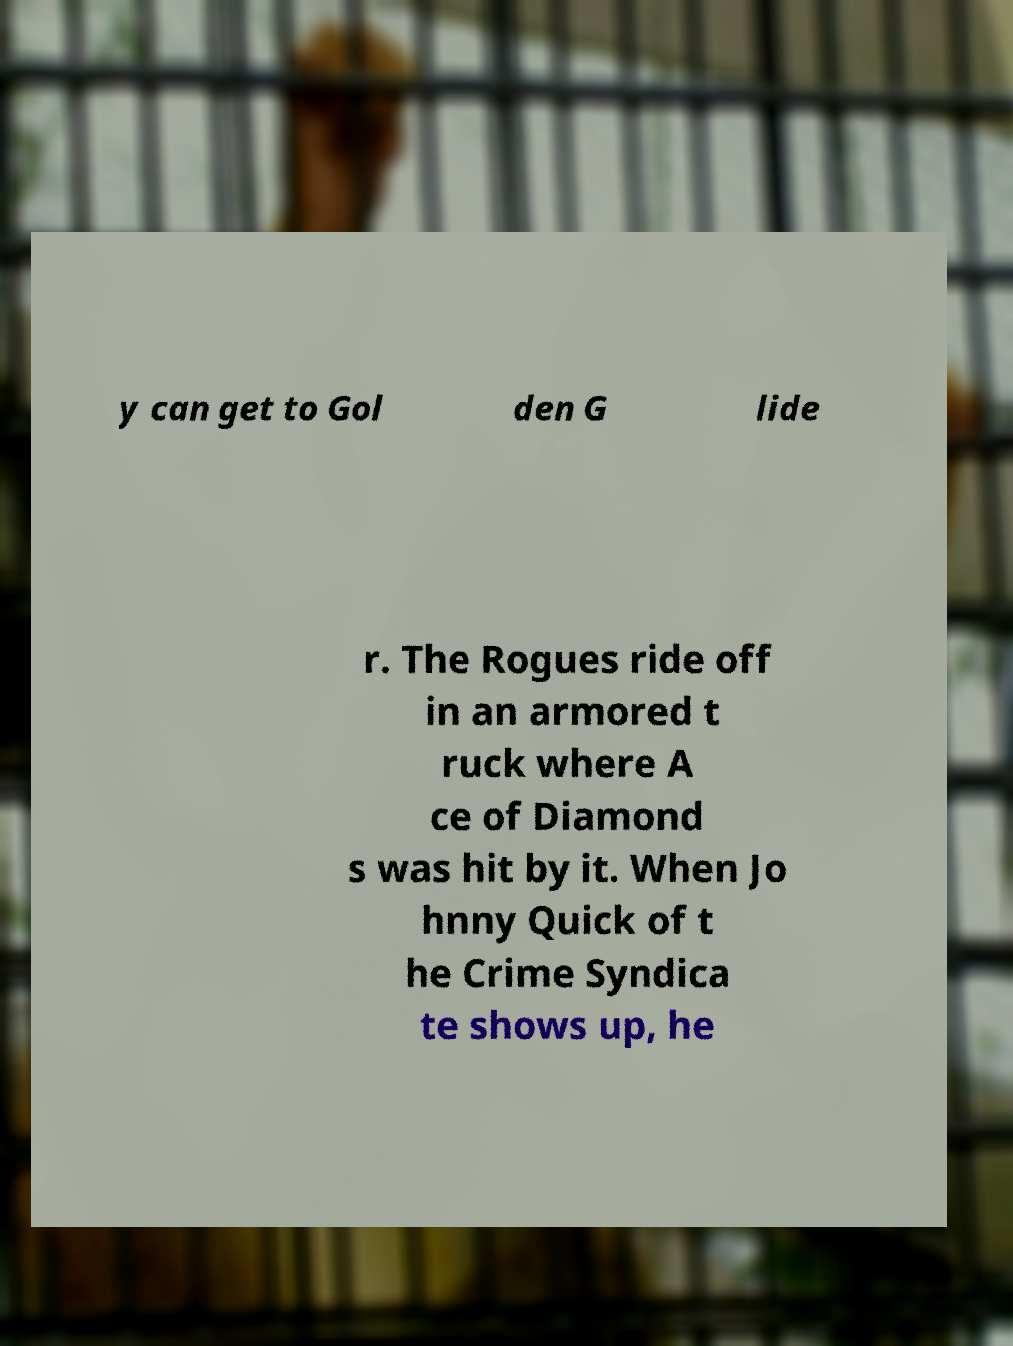Could you assist in decoding the text presented in this image and type it out clearly? y can get to Gol den G lide r. The Rogues ride off in an armored t ruck where A ce of Diamond s was hit by it. When Jo hnny Quick of t he Crime Syndica te shows up, he 